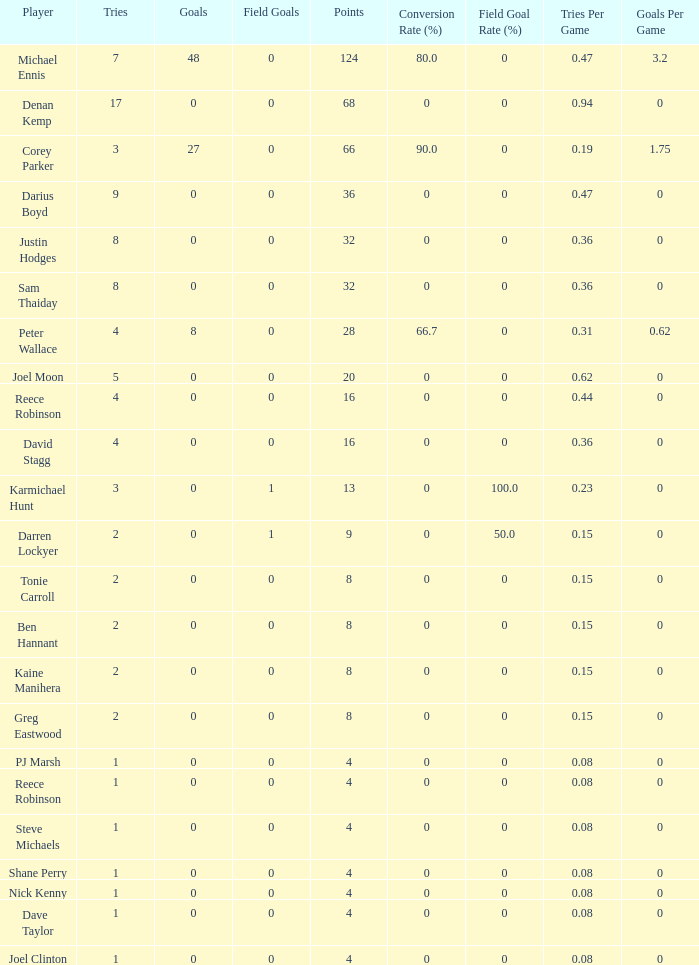What is the total number of field goals of Denan Kemp, who has more than 4 tries, more than 32 points, and 0 goals? 1.0. 